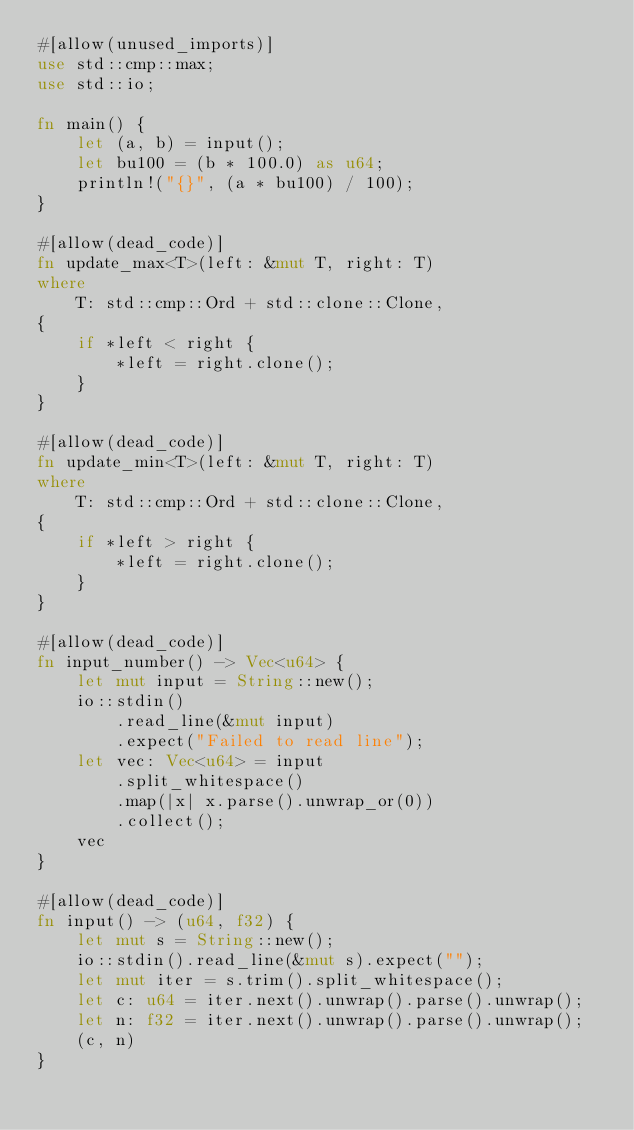<code> <loc_0><loc_0><loc_500><loc_500><_Rust_>#[allow(unused_imports)]
use std::cmp::max;
use std::io;

fn main() {
    let (a, b) = input();
    let bu100 = (b * 100.0) as u64;
    println!("{}", (a * bu100) / 100);
}

#[allow(dead_code)]
fn update_max<T>(left: &mut T, right: T)
where
    T: std::cmp::Ord + std::clone::Clone,
{
    if *left < right {
        *left = right.clone();
    }
}

#[allow(dead_code)]
fn update_min<T>(left: &mut T, right: T)
where
    T: std::cmp::Ord + std::clone::Clone,
{
    if *left > right {
        *left = right.clone();
    }
}

#[allow(dead_code)]
fn input_number() -> Vec<u64> {
    let mut input = String::new();
    io::stdin()
        .read_line(&mut input)
        .expect("Failed to read line");
    let vec: Vec<u64> = input
        .split_whitespace()
        .map(|x| x.parse().unwrap_or(0))
        .collect();
    vec
}

#[allow(dead_code)]
fn input() -> (u64, f32) {
    let mut s = String::new();
    io::stdin().read_line(&mut s).expect("");
    let mut iter = s.trim().split_whitespace();
    let c: u64 = iter.next().unwrap().parse().unwrap();
    let n: f32 = iter.next().unwrap().parse().unwrap();
    (c, n)
}
</code> 